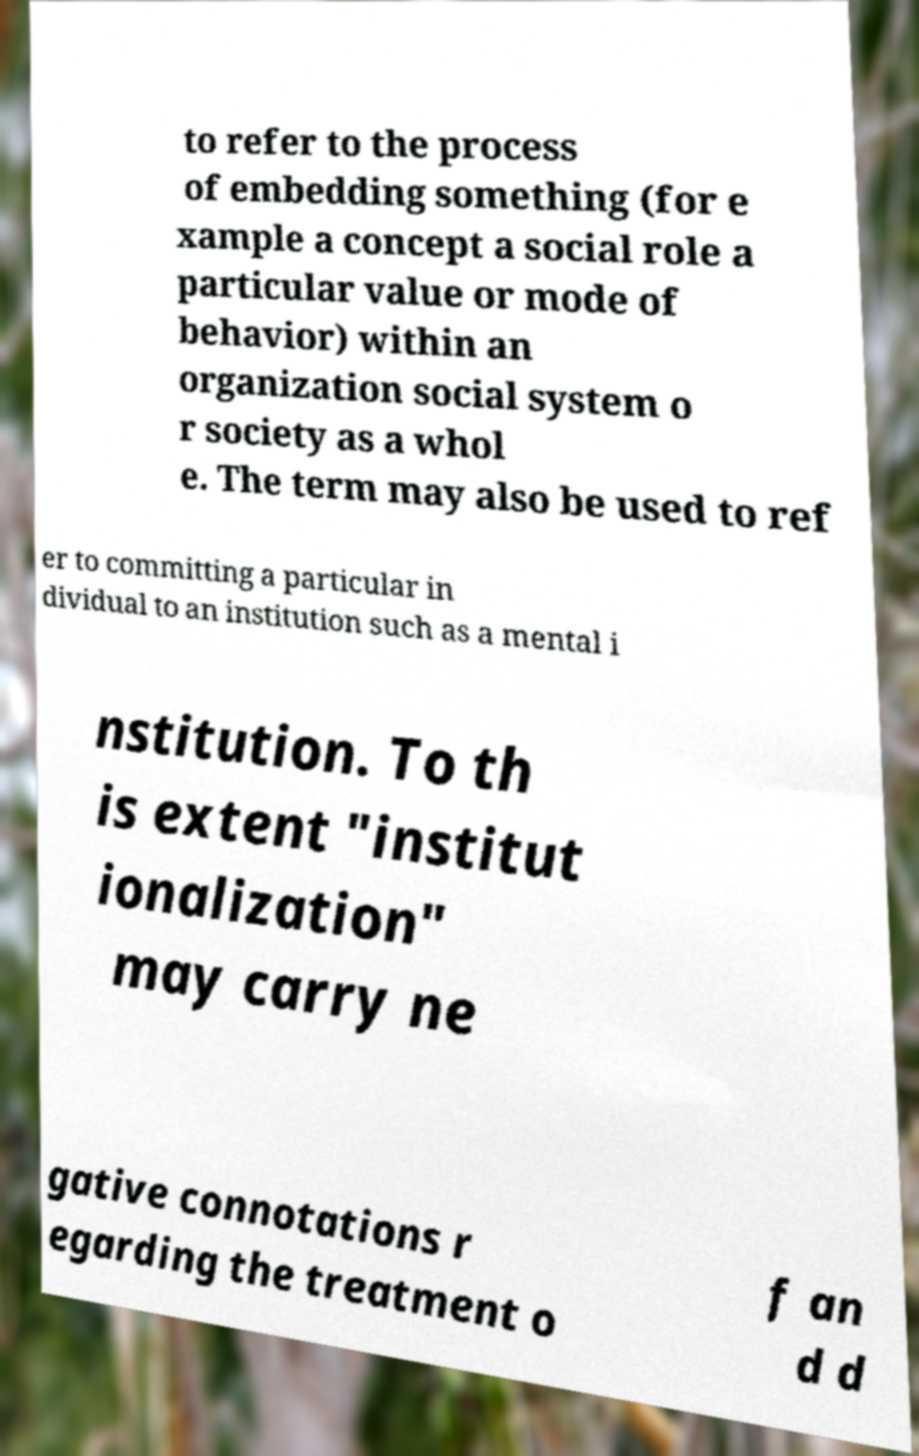What messages or text are displayed in this image? I need them in a readable, typed format. to refer to the process of embedding something (for e xample a concept a social role a particular value or mode of behavior) within an organization social system o r society as a whol e. The term may also be used to ref er to committing a particular in dividual to an institution such as a mental i nstitution. To th is extent "institut ionalization" may carry ne gative connotations r egarding the treatment o f an d d 